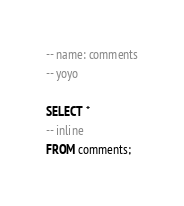Convert code to text. <code><loc_0><loc_0><loc_500><loc_500><_SQL_>
-- name: comments
-- yoyo

SELECT *
-- inline
FROM comments;
</code> 